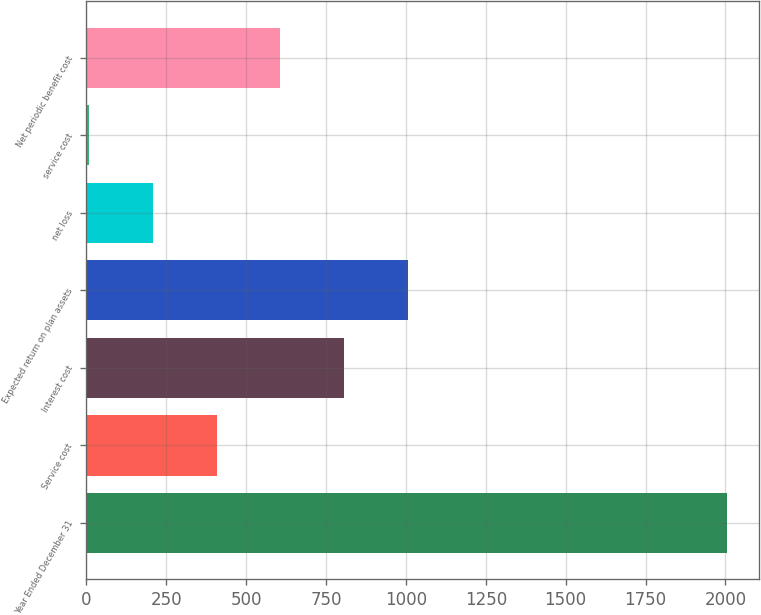Convert chart. <chart><loc_0><loc_0><loc_500><loc_500><bar_chart><fcel>Year Ended December 31<fcel>Service cost<fcel>Interest cost<fcel>Expected return on plan assets<fcel>net loss<fcel>service cost<fcel>Net periodic benefit cost<nl><fcel>2005<fcel>407.4<fcel>806.8<fcel>1006.5<fcel>207.7<fcel>8<fcel>607.1<nl></chart> 